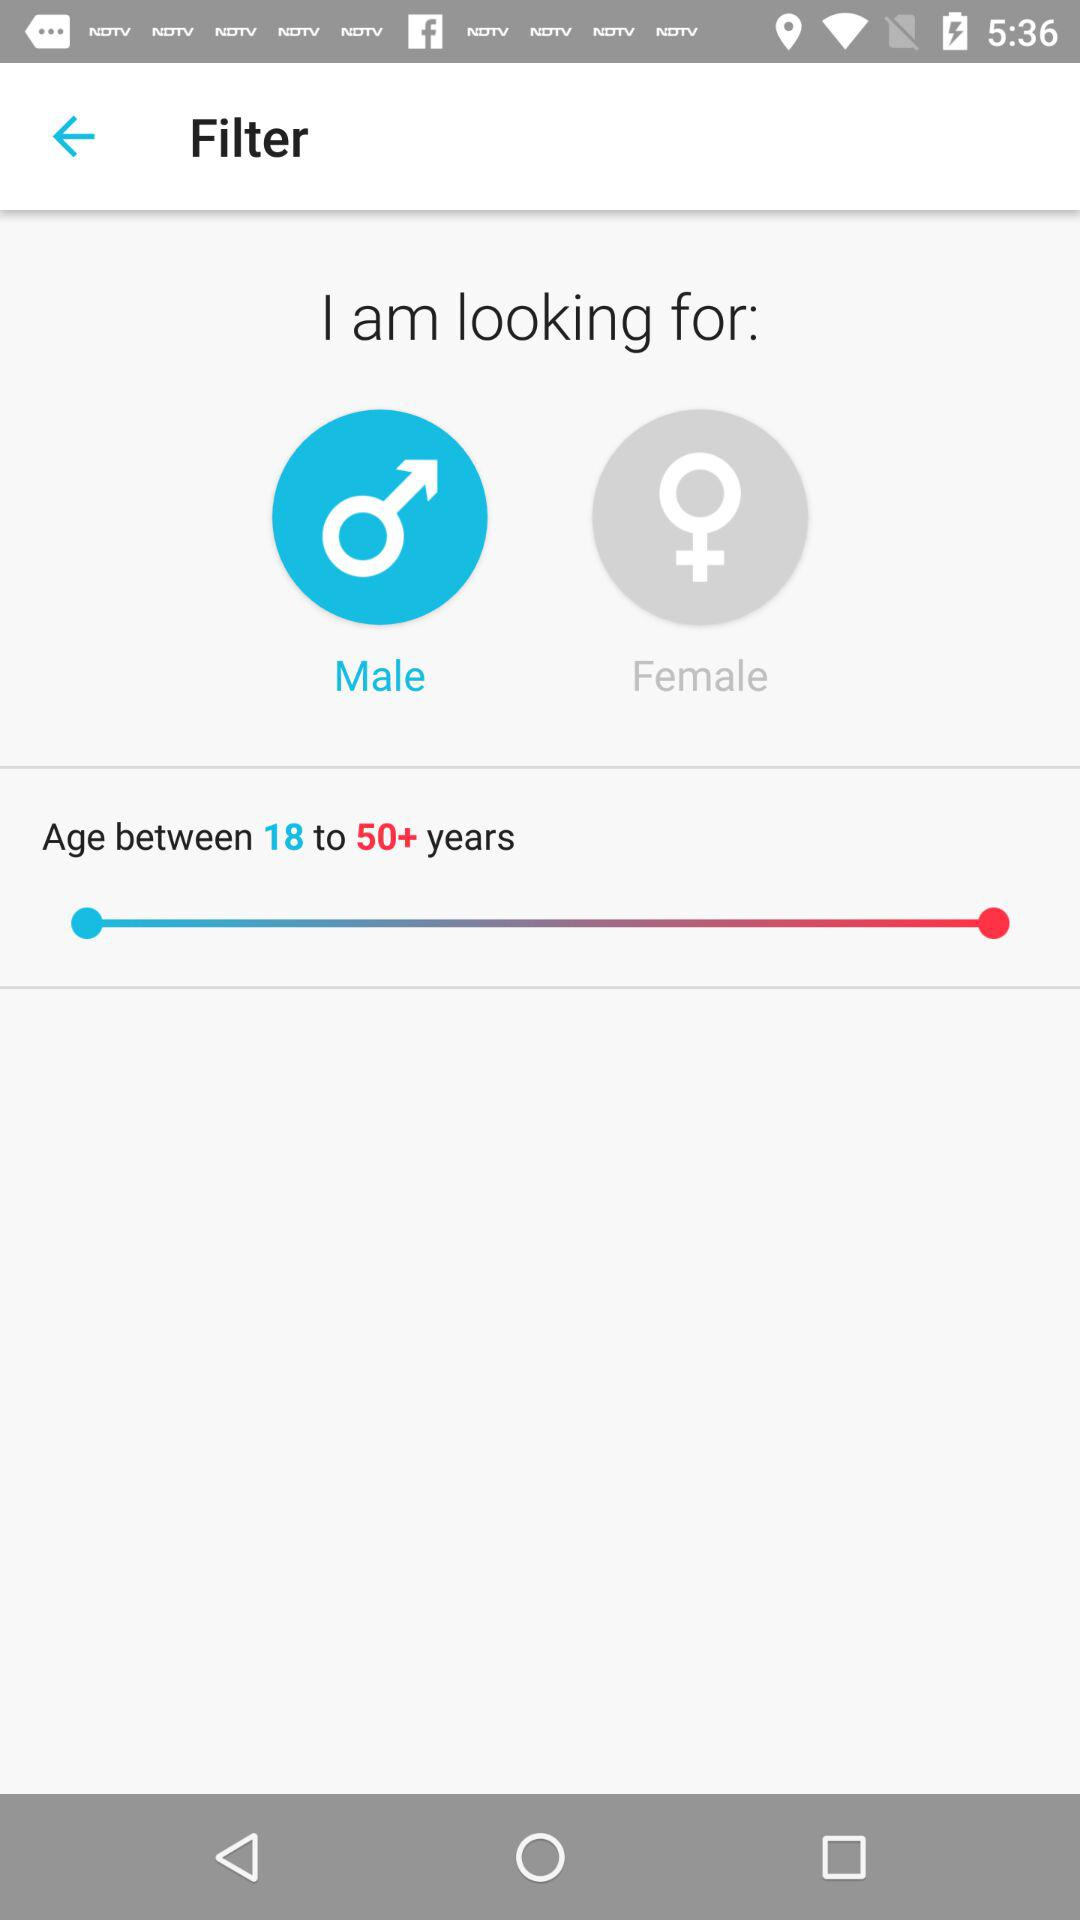What gender is selected in the filter? The selected gender is "Male". 